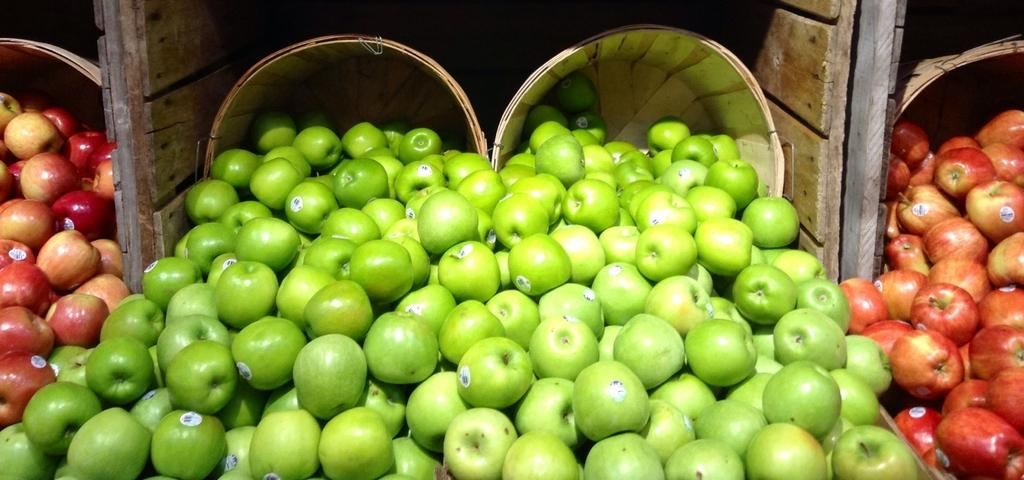What type of apples can be seen in the image? There are green apples and red apples in the image. How can you identify the apples in the image? The apples have stickers on them. What can be seen in the background of the image? There are baskets and wooden planks in the background of the image. What type of winter clothing is being worn by the apples in the image? There is no winter clothing present in the image, as the subjects are apples and not people. 